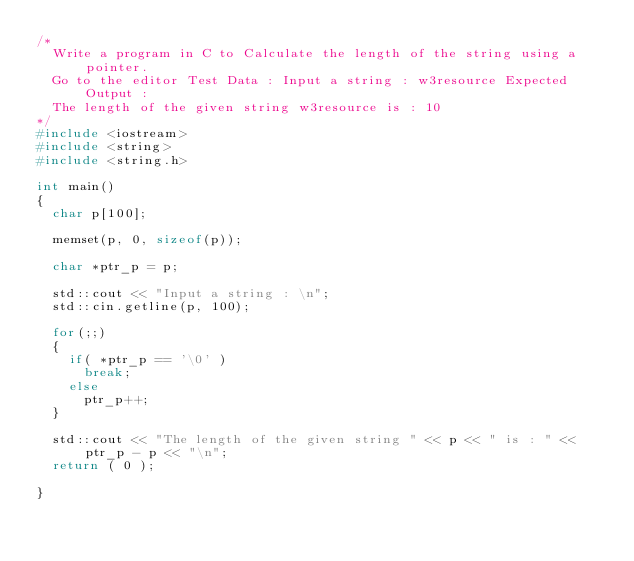Convert code to text. <code><loc_0><loc_0><loc_500><loc_500><_C++_>/*
	Write a program in C to Calculate the length of the string using a pointer. 
	Go to the editor Test Data : Input a string : w3resource Expected Output :
	The length of the given string w3resource is : 10
*/
#include <iostream>
#include <string>
#include <string.h>

int main()
{
	char p[100];

	memset(p, 0, sizeof(p));

	char *ptr_p = p;

	std::cout << "Input a string : \n";
	std::cin.getline(p, 100);

	for(;;)
	{
		if( *ptr_p == '\0' )
			break;
		else
			ptr_p++;
	}

	std::cout << "The length of the given string " << p << " is : " << ptr_p - p << "\n";
	return ( 0 );

}
</code> 